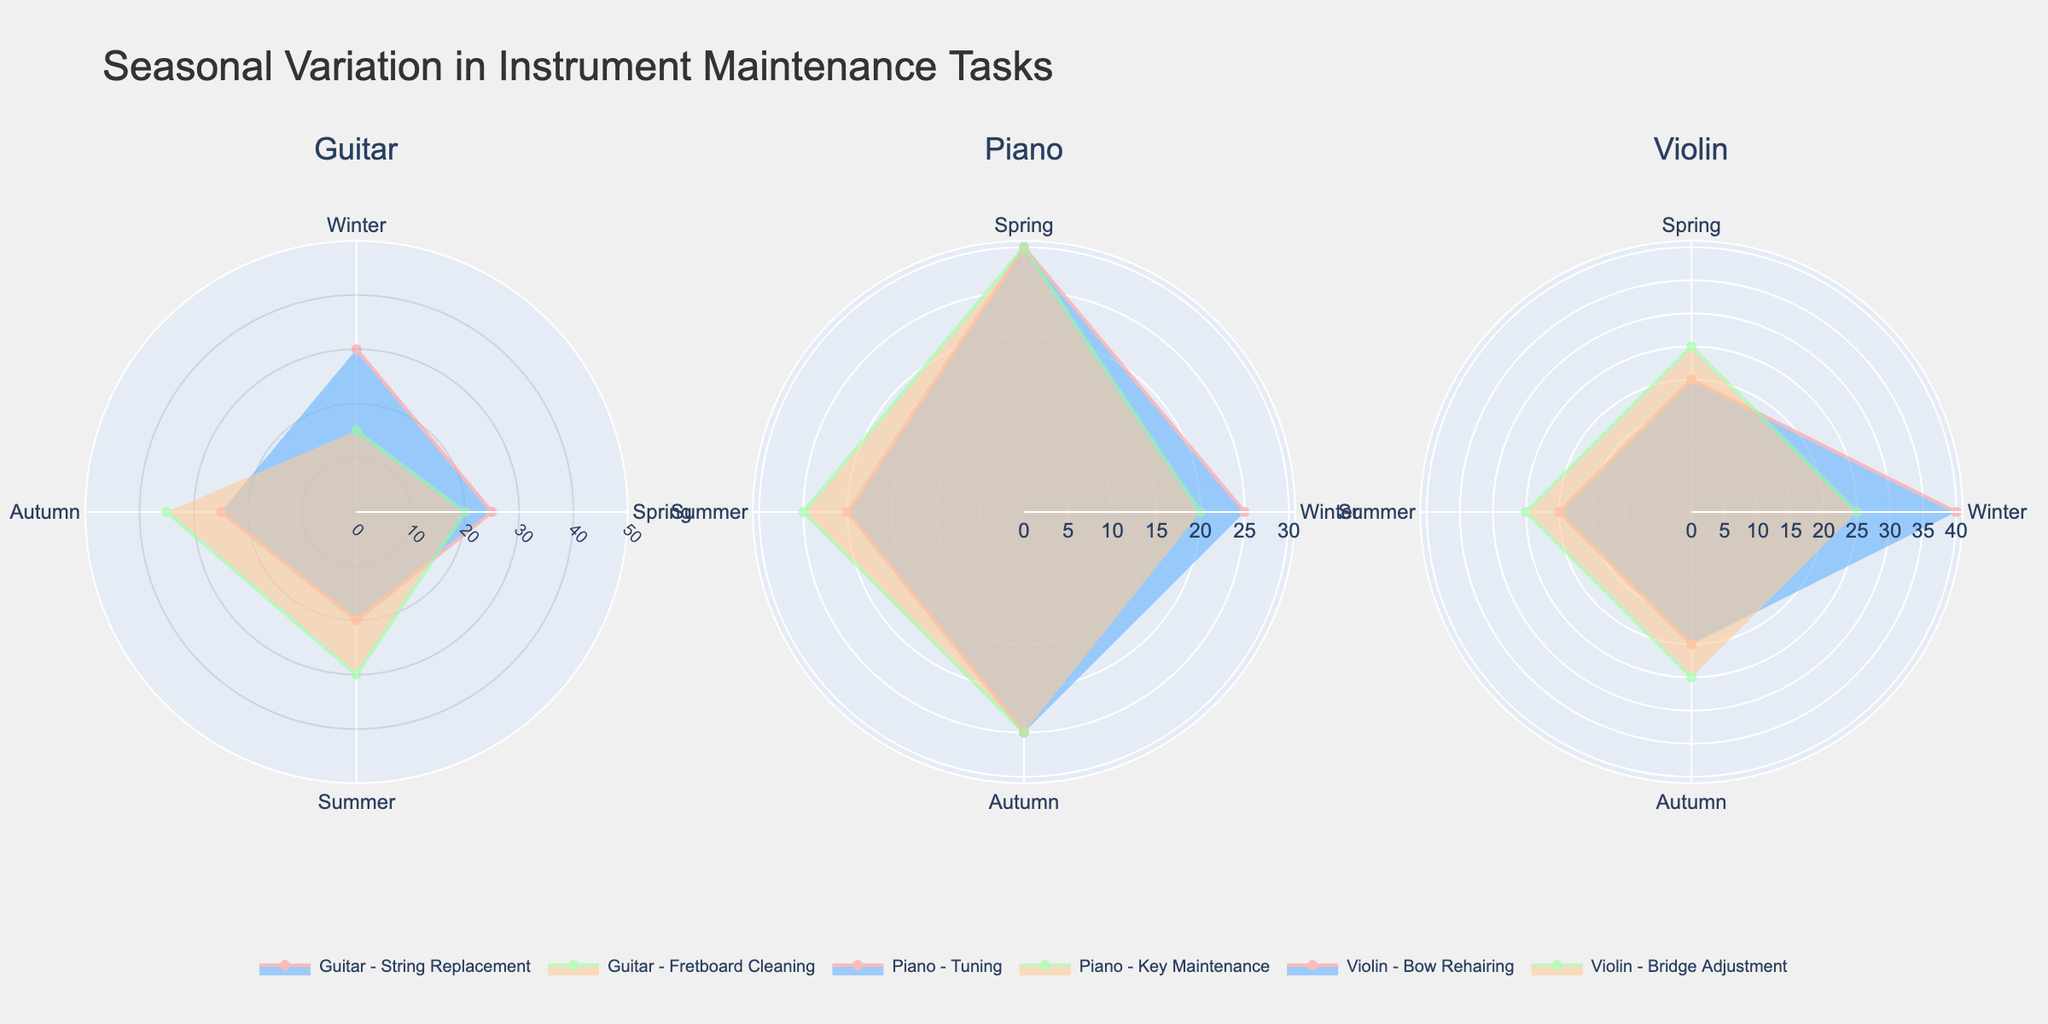What's the title of the figure? The title is prominently displayed at the top of the figure. The title in this case reads 'Seasonal Variation in Instrument Maintenance Tasks'.
Answer: Seasonal Variation in Instrument Maintenance Tasks What color represents the 'Guitar - String Replacement' task? The colors assigned to the tasks are consistent across the subplots, and from the data, the 'Guitar - String Replacement' task has colors '#FF9999' for the line and '#66B2FF' for the fill.
Answer: The line color is pink and the fill color is blue Which season has the highest percentage for 'Violin - Bow Rehairing'? By looking at the polar chart for the 'Violin - Bow Rehairing' task, the highest radial value (percentage) corresponds to 'Winter'.
Answer: Winter How many tasks are displayed in each subplot? Each subplot represents two tasks for a specific instrument, as indicated by the data and legends.
Answer: 2 Which instrument and task have the smallest variation in percentage across the seasons? By examining the filled areas of the polar plots, 'Violin - Bridge Adjustment' shows the smallest variation as the percentage is constant (25%) across all seasons.
Answer: Violin - Bridge Adjustment What is the combined percentage for 'Piano - Key Maintenance' in Spring and Autumn? From the polar chart data, the percentage for 'Piano - Key Maintenance' in Spring is 30%, and in Autumn is 25%. Adding these gives 30% + 25% = 55%.
Answer: 55% Which instrument-task combination has the highest percentage in any single season? By checking each polar chart, 'Violin - Bow Rehairing' in Winter has the peak highest percentage at 40%.
Answer: Violin - Bow Rehairing in Winter How does the percentage for 'Guitar - Fretboard Cleaning' change from Winter to Autumn? The radial values for 'Guitar - Fretboard Cleaning' in Winter, Spring, Summer, and Autumn are 15%, 20%, 30%, and 35%, respectively. The percentage increases as we move from Winter to Autumn.
Answer: It increases 